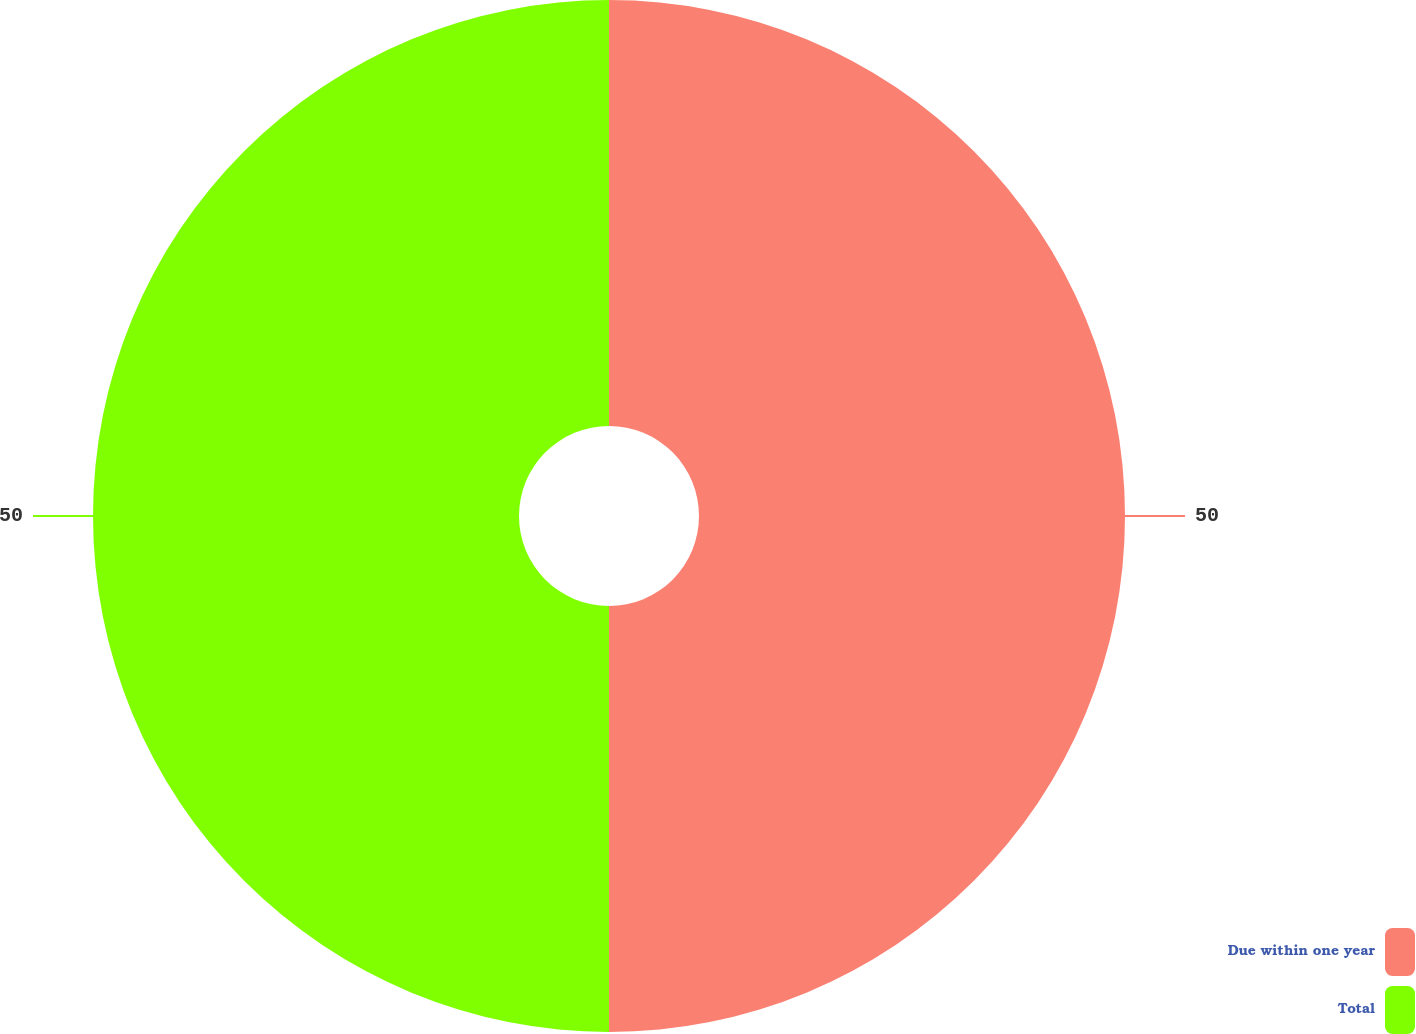<chart> <loc_0><loc_0><loc_500><loc_500><pie_chart><fcel>Due within one year<fcel>Total<nl><fcel>50.0%<fcel>50.0%<nl></chart> 